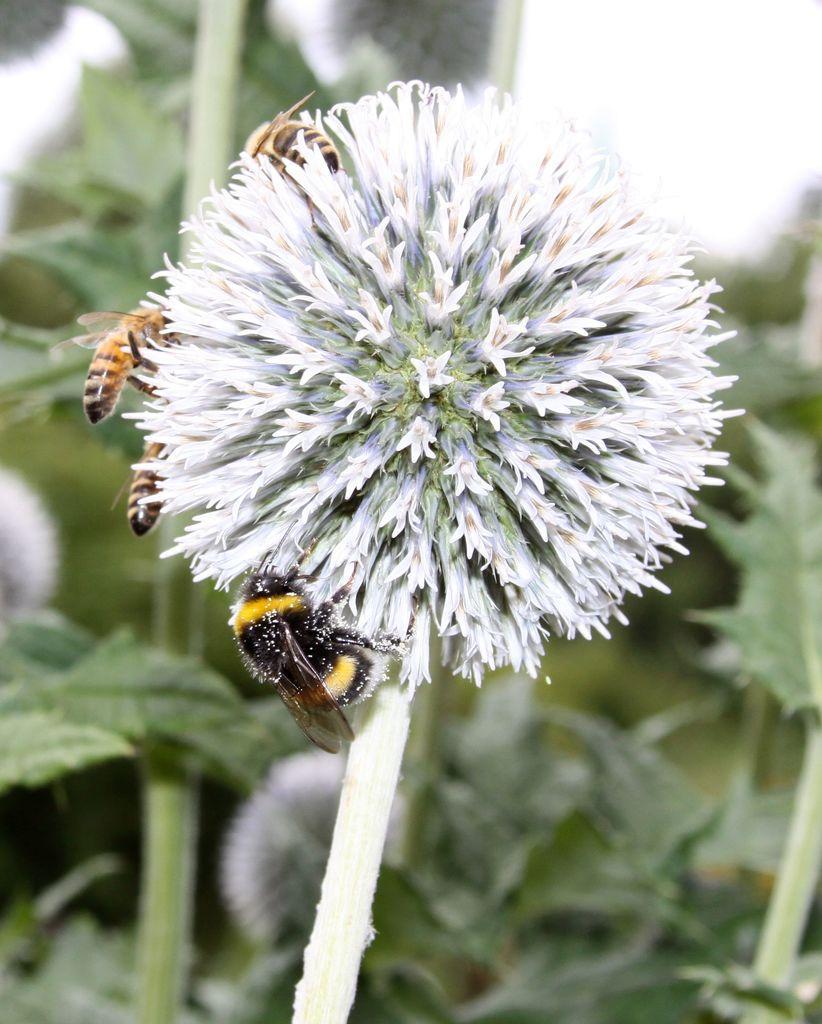Could you give a brief overview of what you see in this image? In this picture I can see a flower in front, on which I can see 4 honey bees. In the background I can see the leaves and I see that it is blurred. 